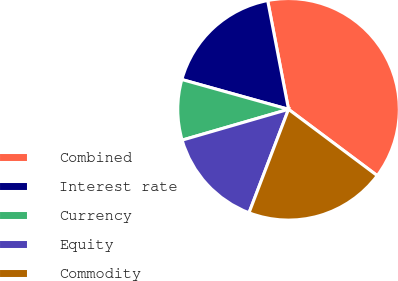Convert chart. <chart><loc_0><loc_0><loc_500><loc_500><pie_chart><fcel>Combined<fcel>Interest rate<fcel>Currency<fcel>Equity<fcel>Commodity<nl><fcel>38.24%<fcel>17.65%<fcel>8.82%<fcel>14.71%<fcel>20.59%<nl></chart> 